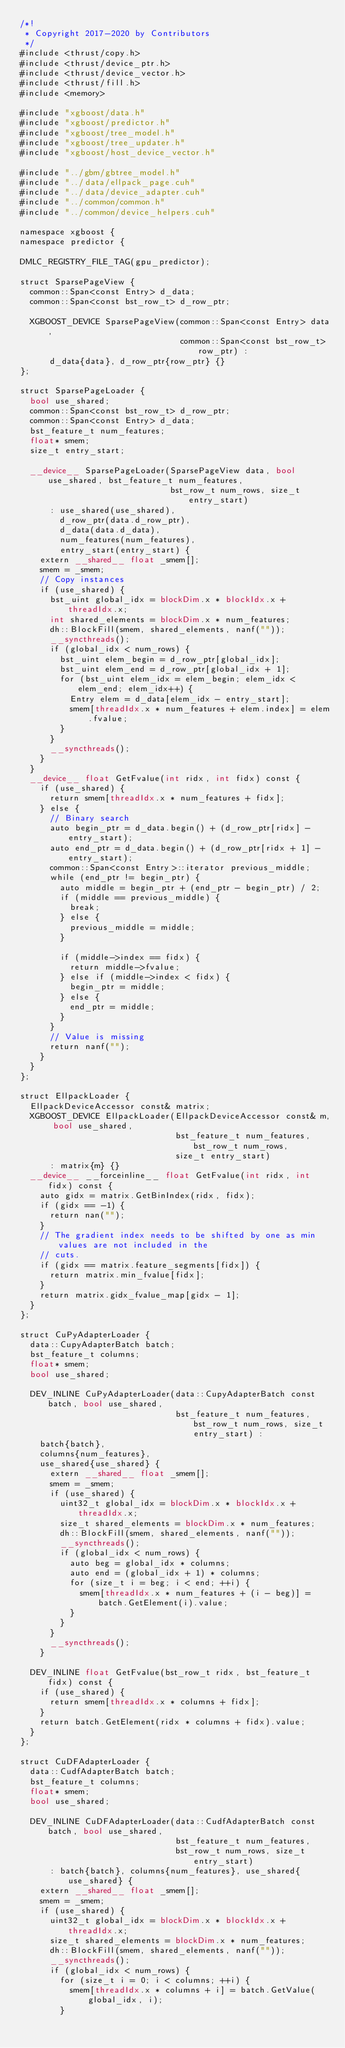<code> <loc_0><loc_0><loc_500><loc_500><_Cuda_>/*!
 * Copyright 2017-2020 by Contributors
 */
#include <thrust/copy.h>
#include <thrust/device_ptr.h>
#include <thrust/device_vector.h>
#include <thrust/fill.h>
#include <memory>

#include "xgboost/data.h"
#include "xgboost/predictor.h"
#include "xgboost/tree_model.h"
#include "xgboost/tree_updater.h"
#include "xgboost/host_device_vector.h"

#include "../gbm/gbtree_model.h"
#include "../data/ellpack_page.cuh"
#include "../data/device_adapter.cuh"
#include "../common/common.h"
#include "../common/device_helpers.cuh"

namespace xgboost {
namespace predictor {

DMLC_REGISTRY_FILE_TAG(gpu_predictor);

struct SparsePageView {
  common::Span<const Entry> d_data;
  common::Span<const bst_row_t> d_row_ptr;

  XGBOOST_DEVICE SparsePageView(common::Span<const Entry> data,
                                common::Span<const bst_row_t> row_ptr) :
      d_data{data}, d_row_ptr{row_ptr} {}
};

struct SparsePageLoader {
  bool use_shared;
  common::Span<const bst_row_t> d_row_ptr;
  common::Span<const Entry> d_data;
  bst_feature_t num_features;
  float* smem;
  size_t entry_start;

  __device__ SparsePageLoader(SparsePageView data, bool use_shared, bst_feature_t num_features,
                              bst_row_t num_rows, size_t entry_start)
      : use_shared(use_shared),
        d_row_ptr(data.d_row_ptr),
        d_data(data.d_data),
        num_features(num_features),
        entry_start(entry_start) {
    extern __shared__ float _smem[];
    smem = _smem;
    // Copy instances
    if (use_shared) {
      bst_uint global_idx = blockDim.x * blockIdx.x + threadIdx.x;
      int shared_elements = blockDim.x * num_features;
      dh::BlockFill(smem, shared_elements, nanf(""));
      __syncthreads();
      if (global_idx < num_rows) {
        bst_uint elem_begin = d_row_ptr[global_idx];
        bst_uint elem_end = d_row_ptr[global_idx + 1];
        for (bst_uint elem_idx = elem_begin; elem_idx < elem_end; elem_idx++) {
          Entry elem = d_data[elem_idx - entry_start];
          smem[threadIdx.x * num_features + elem.index] = elem.fvalue;
        }
      }
      __syncthreads();
    }
  }
  __device__ float GetFvalue(int ridx, int fidx) const {
    if (use_shared) {
      return smem[threadIdx.x * num_features + fidx];
    } else {
      // Binary search
      auto begin_ptr = d_data.begin() + (d_row_ptr[ridx] - entry_start);
      auto end_ptr = d_data.begin() + (d_row_ptr[ridx + 1] - entry_start);
      common::Span<const Entry>::iterator previous_middle;
      while (end_ptr != begin_ptr) {
        auto middle = begin_ptr + (end_ptr - begin_ptr) / 2;
        if (middle == previous_middle) {
          break;
        } else {
          previous_middle = middle;
        }

        if (middle->index == fidx) {
          return middle->fvalue;
        } else if (middle->index < fidx) {
          begin_ptr = middle;
        } else {
          end_ptr = middle;
        }
      }
      // Value is missing
      return nanf("");
    }
  }
};

struct EllpackLoader {
  EllpackDeviceAccessor const& matrix;
  XGBOOST_DEVICE EllpackLoader(EllpackDeviceAccessor const& m, bool use_shared,
                               bst_feature_t num_features, bst_row_t num_rows,
                               size_t entry_start)
      : matrix{m} {}
  __device__ __forceinline__ float GetFvalue(int ridx, int fidx) const {
    auto gidx = matrix.GetBinIndex(ridx, fidx);
    if (gidx == -1) {
      return nan("");
    }
    // The gradient index needs to be shifted by one as min values are not included in the
    // cuts.
    if (gidx == matrix.feature_segments[fidx]) {
      return matrix.min_fvalue[fidx];
    }
    return matrix.gidx_fvalue_map[gidx - 1];
  }
};

struct CuPyAdapterLoader {
  data::CupyAdapterBatch batch;
  bst_feature_t columns;
  float* smem;
  bool use_shared;

  DEV_INLINE CuPyAdapterLoader(data::CupyAdapterBatch const batch, bool use_shared,
                               bst_feature_t num_features, bst_row_t num_rows, size_t entry_start) :
    batch{batch},
    columns{num_features},
    use_shared{use_shared} {
      extern __shared__ float _smem[];
      smem = _smem;
      if (use_shared) {
        uint32_t global_idx = blockDim.x * blockIdx.x + threadIdx.x;
        size_t shared_elements = blockDim.x * num_features;
        dh::BlockFill(smem, shared_elements, nanf(""));
        __syncthreads();
        if (global_idx < num_rows) {
          auto beg = global_idx * columns;
          auto end = (global_idx + 1) * columns;
          for (size_t i = beg; i < end; ++i) {
            smem[threadIdx.x * num_features + (i - beg)] = batch.GetElement(i).value;
          }
        }
      }
      __syncthreads();
    }

  DEV_INLINE float GetFvalue(bst_row_t ridx, bst_feature_t fidx) const {
    if (use_shared) {
      return smem[threadIdx.x * columns + fidx];
    }
    return batch.GetElement(ridx * columns + fidx).value;
  }
};

struct CuDFAdapterLoader {
  data::CudfAdapterBatch batch;
  bst_feature_t columns;
  float* smem;
  bool use_shared;

  DEV_INLINE CuDFAdapterLoader(data::CudfAdapterBatch const batch, bool use_shared,
                               bst_feature_t num_features,
                               bst_row_t num_rows, size_t entry_start)
      : batch{batch}, columns{num_features}, use_shared{use_shared} {
    extern __shared__ float _smem[];
    smem = _smem;
    if (use_shared) {
      uint32_t global_idx = blockDim.x * blockIdx.x + threadIdx.x;
      size_t shared_elements = blockDim.x * num_features;
      dh::BlockFill(smem, shared_elements, nanf(""));
      __syncthreads();
      if (global_idx < num_rows) {
        for (size_t i = 0; i < columns; ++i) {
          smem[threadIdx.x * columns + i] = batch.GetValue(global_idx, i);
        }</code> 